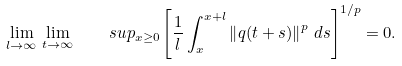Convert formula to latex. <formula><loc_0><loc_0><loc_500><loc_500>\lim _ { l \rightarrow \infty } \, \lim _ { t \rightarrow \infty } \quad s u p _ { x \geq 0 } \left [ \frac { 1 } { l } \int _ { x } ^ { x + l } \left \| q ( t + s ) \right \| ^ { p } \, d s \right ] ^ { 1 / p } = 0 .</formula> 